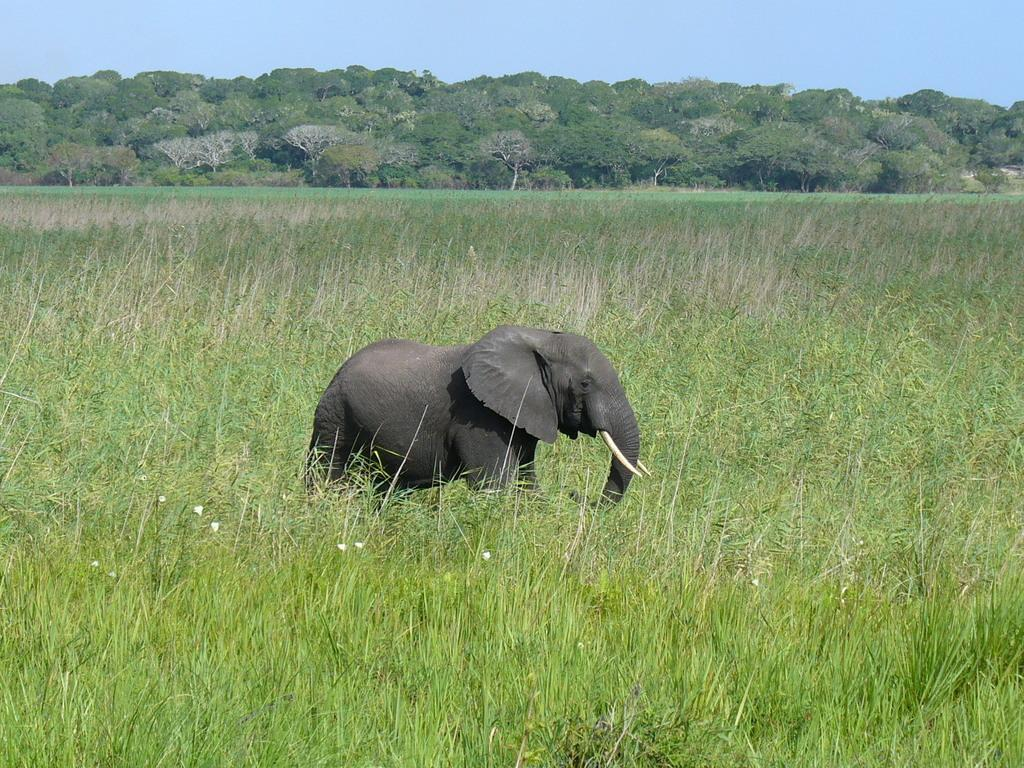What animal is present in the image? There is an elephant in the image. What color is the elephant? The elephant is gray in color. Where is the elephant located? The elephant is on the ground. What type of vegetation is on the ground? There is grass on the ground. What can be seen in the background of the image? There are trees on a mountain in the background, and the sky is blue. What type of roof can be seen on the elephant in the image? There is no roof present on the elephant in the image, as it is an animal and not a structure. 